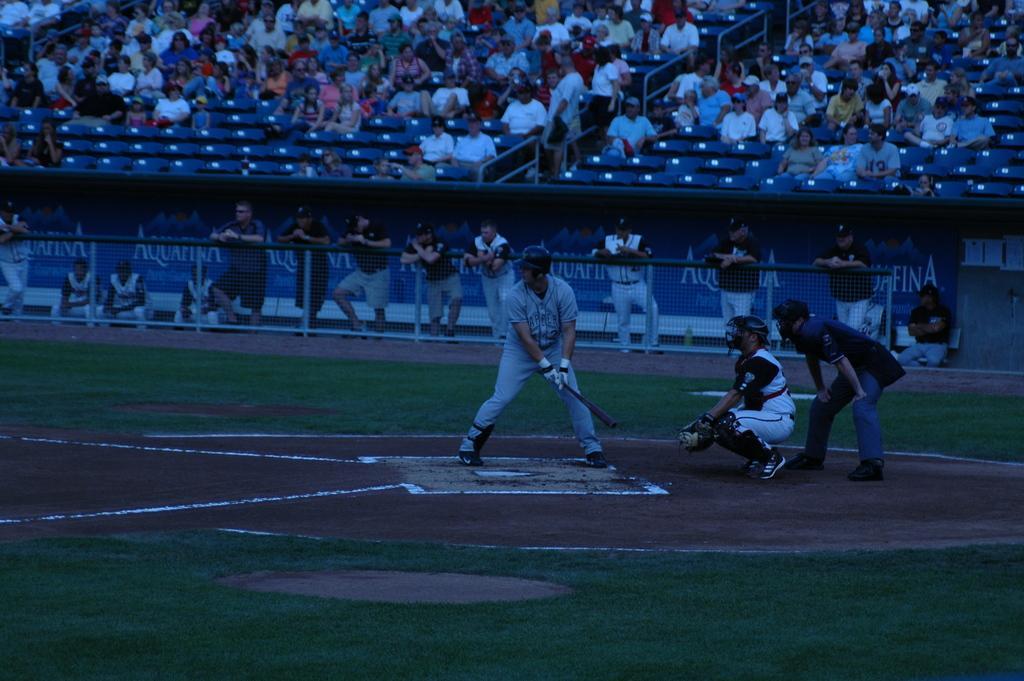Can you describe this image briefly? In this image I can see three people are on the ground. One person is holding the base ball bat and these people are wearing the helmets and also gloves. In the back I can see few people are standing behind the railing. In the background I can see the group of people sitting and wearing the different color dresses. 